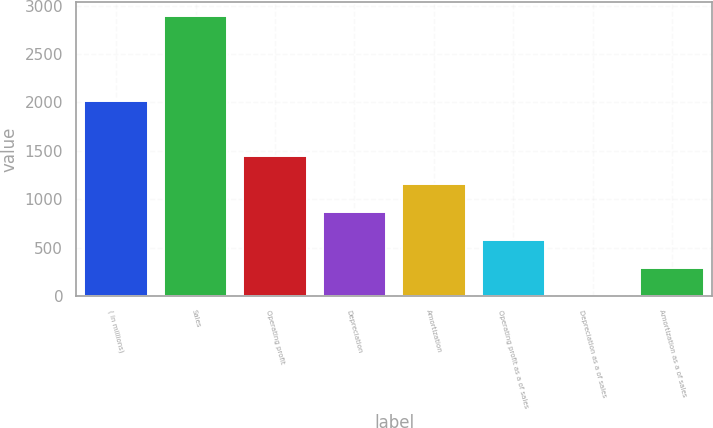<chart> <loc_0><loc_0><loc_500><loc_500><bar_chart><fcel>( in millions)<fcel>Sales<fcel>Operating profit<fcel>Depreciation<fcel>Amortization<fcel>Operating profit as a of sales<fcel>Depreciation as a of sales<fcel>Amortization as a of sales<nl><fcel>2016<fcel>2891.6<fcel>1446.4<fcel>868.32<fcel>1157.36<fcel>579.28<fcel>1.2<fcel>290.24<nl></chart> 